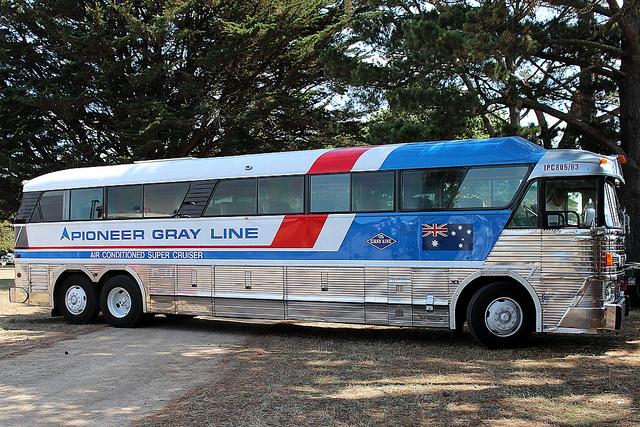What flag is on the bus?
Quick response, please. England. Is this a greyhound?
Be succinct. No. Are any people visible?
Keep it brief. No. 